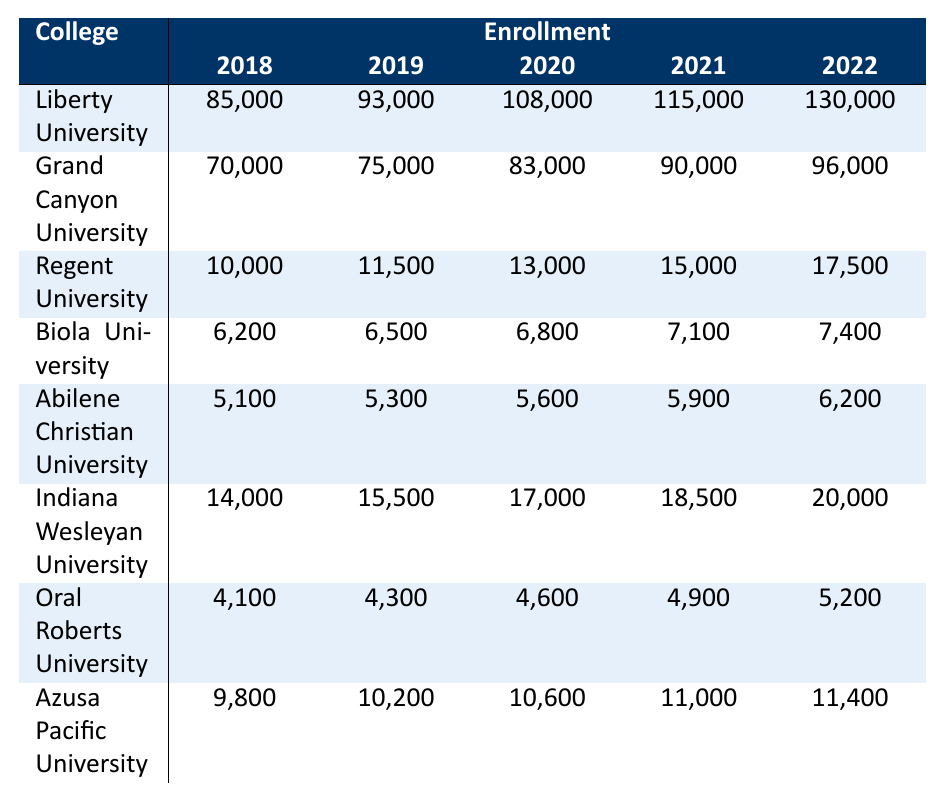What was the enrollment of Liberty University in 2020? The table shows that Liberty University had an enrollment of 108,000 in 2020.
Answer: 108,000 Which college had the highest enrollment in 2022? Referring to the table, Liberty University had the highest enrollment of 130,000 in 2022.
Answer: Liberty University What is the difference in enrollment for Indiana Wesleyan University between 2018 and 2022? For Indiana Wesleyan University, the enrollment in 2018 was 14,000 and in 2022 was 20,000. The difference is 20,000 - 14,000 = 6,000.
Answer: 6,000 What is the average enrollment for Biola University from 2018 to 2022? The enrollments for Biola University from 2018 to 2022 are 6,200, 6,500, 6,800, 7,100, and 7,400. Summing these gives 6,200 + 6,500 + 6,800 + 7,100 + 7,400 = 33,000. Dividing by 5 gives the average: 33,000 / 5 = 6,600.
Answer: 6,600 Did Azusa Pacific University have an enrollment greater than 10,000 in any year? Looking at the table, Azusa Pacific University's enrollment reached 11,000 in 2021 and 11,400 in 2022, confirming it did exceed 10,000 in those years.
Answer: Yes Which college showed the largest increase in enrollment from 2018 to 2022? Calculating the increases: Liberty University: 130,000 - 85,000 = 45,000; Grand Canyon University: 96,000 - 70,000 = 26,000; Indiana Wesleyan University: 20,000 - 14,000 = 6,000; The largest increase of 45,000 belongs to Liberty University.
Answer: Liberty University What was the enrollment trend for Regent University from 2018 to 2022? Each year the enrollment for Regent University increased: 10,000 in 2018, reaching 17,500 in 2022. This shows a consistent upward trend.
Answer: Increasing What's the total enrollment across all colleges for the year 2021? Adding the enrollments for 2021 from each college: 115,000 (Liberty) + 90,000 (Grand Canyon) + 15,000 (Regent) + 7,100 (Biola) + 5,900 (Abilene) + 18,500 (Indiana Wesleyan) + 4,900 (Oral Roberts) + 11,000 (Azusa Pacific) totals 263,400.
Answer: 263,400 Did any college have an enrollment of less than 7,000 in every year? By checking the enrollments for each college, Oral Roberts University had less than 7,000 every year, maxing out at 5,200 in 2022.
Answer: Yes What percentage of the total 2022 enrollment for Christian colleges does Liberty University represent? The total 2022 enrollment is 130,000 (Liberty) + 96,000 (Grand Canyon) + 17,500 (Regent) + 7,400 (Biola) + 6,200 (Abilene) + 20,000 (Indiana Wesleyan) + 5,200 (Oral Roberts) + 11,400 (Azusa Pacific), summing up to 293,700. Liberty's enrollment represents (130,000 / 293,700) * 100 ≈ 44.3%.
Answer: Approximately 44.3% 